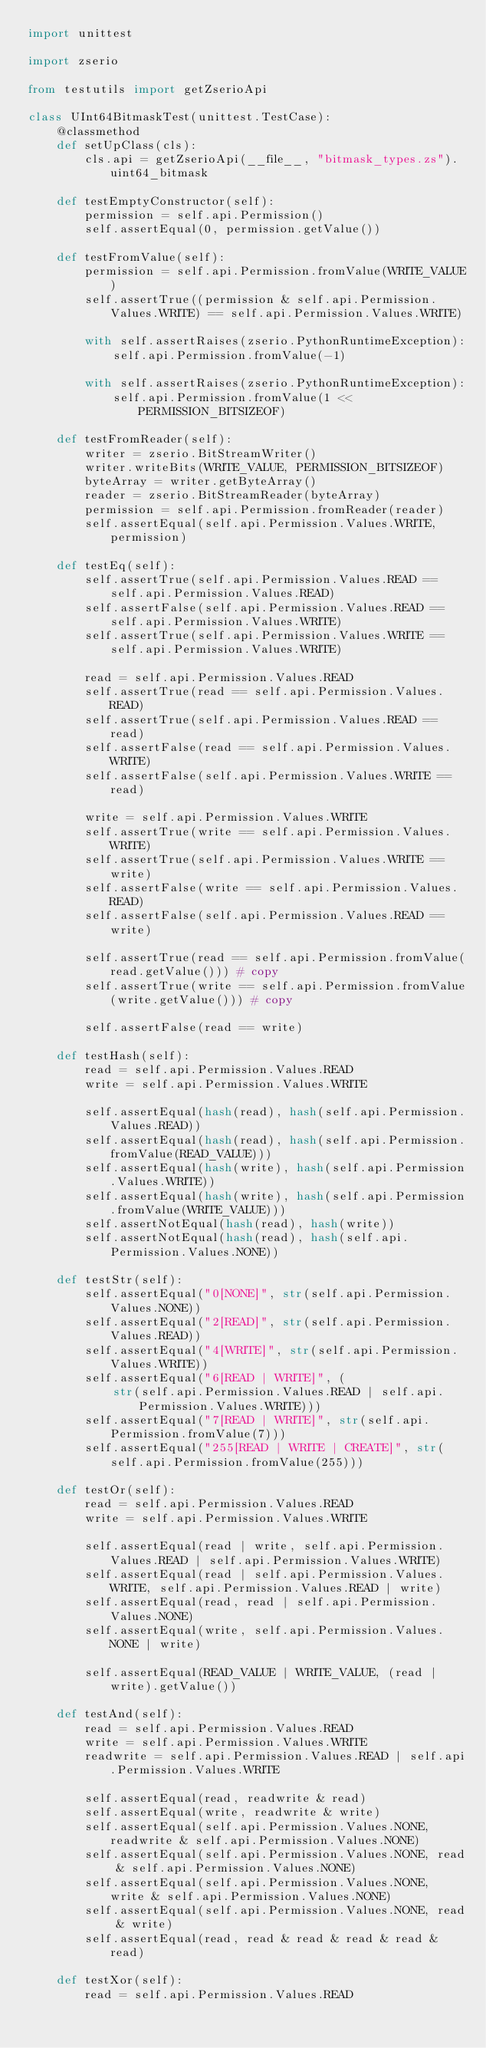Convert code to text. <code><loc_0><loc_0><loc_500><loc_500><_Python_>import unittest

import zserio

from testutils import getZserioApi

class UInt64BitmaskTest(unittest.TestCase):
    @classmethod
    def setUpClass(cls):
        cls.api = getZserioApi(__file__, "bitmask_types.zs").uint64_bitmask

    def testEmptyConstructor(self):
        permission = self.api.Permission()
        self.assertEqual(0, permission.getValue())

    def testFromValue(self):
        permission = self.api.Permission.fromValue(WRITE_VALUE)
        self.assertTrue((permission & self.api.Permission.Values.WRITE) == self.api.Permission.Values.WRITE)

        with self.assertRaises(zserio.PythonRuntimeException):
            self.api.Permission.fromValue(-1)

        with self.assertRaises(zserio.PythonRuntimeException):
            self.api.Permission.fromValue(1 << PERMISSION_BITSIZEOF)

    def testFromReader(self):
        writer = zserio.BitStreamWriter()
        writer.writeBits(WRITE_VALUE, PERMISSION_BITSIZEOF)
        byteArray = writer.getByteArray()
        reader = zserio.BitStreamReader(byteArray)
        permission = self.api.Permission.fromReader(reader)
        self.assertEqual(self.api.Permission.Values.WRITE, permission)

    def testEq(self):
        self.assertTrue(self.api.Permission.Values.READ == self.api.Permission.Values.READ)
        self.assertFalse(self.api.Permission.Values.READ == self.api.Permission.Values.WRITE)
        self.assertTrue(self.api.Permission.Values.WRITE == self.api.Permission.Values.WRITE)

        read = self.api.Permission.Values.READ
        self.assertTrue(read == self.api.Permission.Values.READ)
        self.assertTrue(self.api.Permission.Values.READ == read)
        self.assertFalse(read == self.api.Permission.Values.WRITE)
        self.assertFalse(self.api.Permission.Values.WRITE == read)

        write = self.api.Permission.Values.WRITE
        self.assertTrue(write == self.api.Permission.Values.WRITE)
        self.assertTrue(self.api.Permission.Values.WRITE == write)
        self.assertFalse(write == self.api.Permission.Values.READ)
        self.assertFalse(self.api.Permission.Values.READ == write)

        self.assertTrue(read == self.api.Permission.fromValue(read.getValue())) # copy
        self.assertTrue(write == self.api.Permission.fromValue(write.getValue())) # copy

        self.assertFalse(read == write)

    def testHash(self):
        read = self.api.Permission.Values.READ
        write = self.api.Permission.Values.WRITE

        self.assertEqual(hash(read), hash(self.api.Permission.Values.READ))
        self.assertEqual(hash(read), hash(self.api.Permission.fromValue(READ_VALUE)))
        self.assertEqual(hash(write), hash(self.api.Permission.Values.WRITE))
        self.assertEqual(hash(write), hash(self.api.Permission.fromValue(WRITE_VALUE)))
        self.assertNotEqual(hash(read), hash(write))
        self.assertNotEqual(hash(read), hash(self.api.Permission.Values.NONE))

    def testStr(self):
        self.assertEqual("0[NONE]", str(self.api.Permission.Values.NONE))
        self.assertEqual("2[READ]", str(self.api.Permission.Values.READ))
        self.assertEqual("4[WRITE]", str(self.api.Permission.Values.WRITE))
        self.assertEqual("6[READ | WRITE]", (
            str(self.api.Permission.Values.READ | self.api.Permission.Values.WRITE)))
        self.assertEqual("7[READ | WRITE]", str(self.api.Permission.fromValue(7)))
        self.assertEqual("255[READ | WRITE | CREATE]", str(self.api.Permission.fromValue(255)))

    def testOr(self):
        read = self.api.Permission.Values.READ
        write = self.api.Permission.Values.WRITE

        self.assertEqual(read | write, self.api.Permission.Values.READ | self.api.Permission.Values.WRITE)
        self.assertEqual(read | self.api.Permission.Values.WRITE, self.api.Permission.Values.READ | write)
        self.assertEqual(read, read | self.api.Permission.Values.NONE)
        self.assertEqual(write, self.api.Permission.Values.NONE | write)

        self.assertEqual(READ_VALUE | WRITE_VALUE, (read | write).getValue())

    def testAnd(self):
        read = self.api.Permission.Values.READ
        write = self.api.Permission.Values.WRITE
        readwrite = self.api.Permission.Values.READ | self.api.Permission.Values.WRITE

        self.assertEqual(read, readwrite & read)
        self.assertEqual(write, readwrite & write)
        self.assertEqual(self.api.Permission.Values.NONE, readwrite & self.api.Permission.Values.NONE)
        self.assertEqual(self.api.Permission.Values.NONE, read & self.api.Permission.Values.NONE)
        self.assertEqual(self.api.Permission.Values.NONE, write & self.api.Permission.Values.NONE)
        self.assertEqual(self.api.Permission.Values.NONE, read & write)
        self.assertEqual(read, read & read & read & read & read)

    def testXor(self):
        read = self.api.Permission.Values.READ</code> 